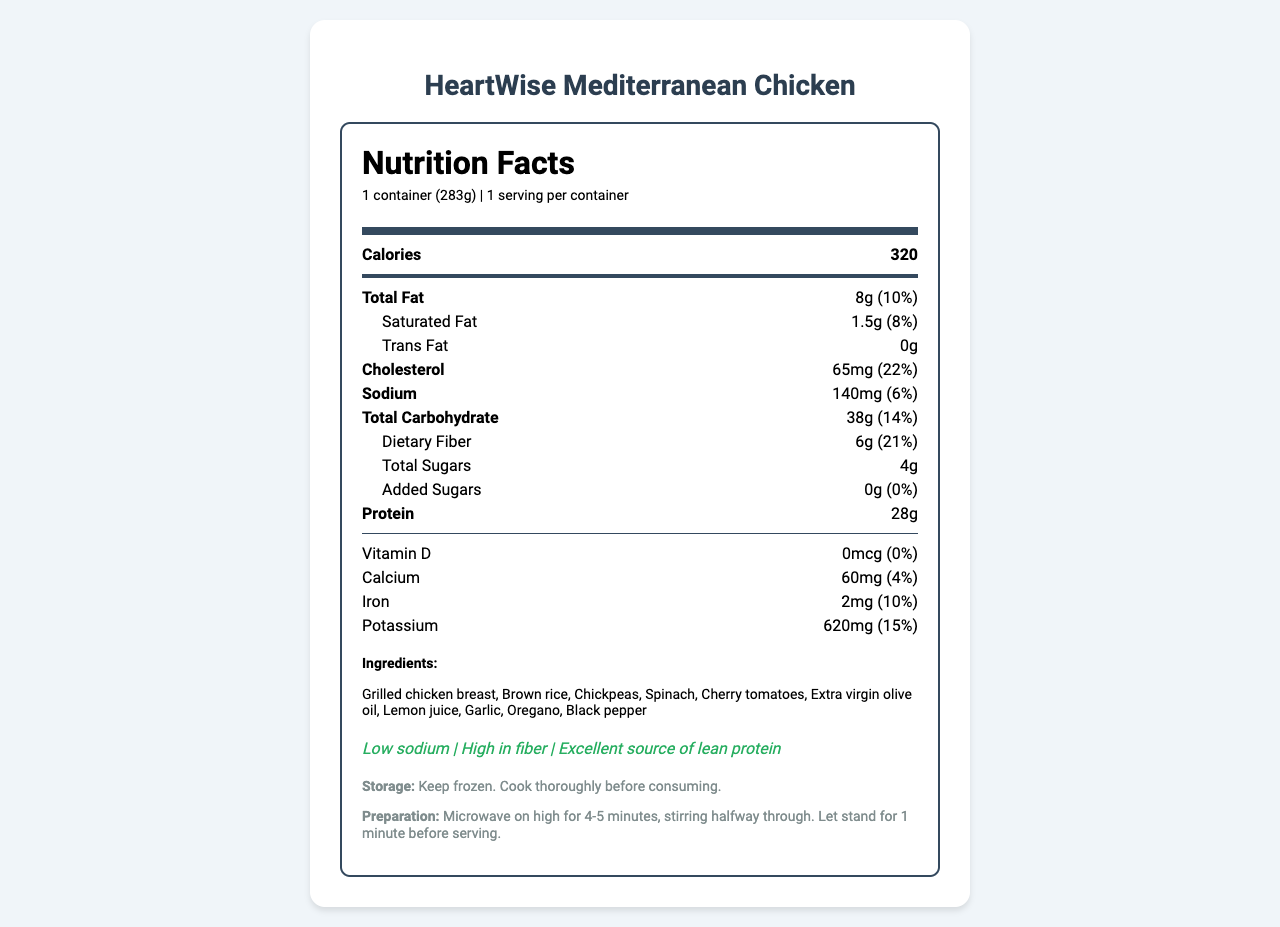what is the serving size? The serving size information is provided right below the product name in the nutrition label section.
Answer: 1 container (283g) how many calories are in one serving? The calories for one serving are listed at the top center of the nutrition facts label.
Answer: 320 what is the amount of sodium in this meal? The sodium amount is listed under the nutrition facts and next to the daily value percentage.
Answer: 140mg how much protein does this meal contain? The protein amount is listed towards the bottom section of the nutrition facts label.
Answer: 28g what is the total fat content? The total fat content is found near the top of the nutrition facts and is written as "Total Fat 8g (10%)".
Answer: 8g (10%) what are the three main health claims made about this product? The health claims are listed towards the bottom of the document under the heading "health-claims".
Answer: Low sodium, High in fiber, Excellent source of lean protein which nutrient has the highest daily value percentage? A. Total Fat B. Cholesterol C. Sodium D. Dietary Fiber E. Protein The daily value percentages for the nutrients are listed next to their amounts, and cholesterol has the highest daily value percentage at 22%.
Answer: B. Cholesterol what ingredient is used as a seasoning in this meal? A. Oregano B. Lemon juice C. Brown rice D. Chicken breast The ingredients list "Oregano" is used as a seasoning, while options B, C, and D are core ingredients.
Answer: A. Oregano is this meal suitable for someone who needs a high calcium diet? The meal provides only 4% of the daily value for calcium, which is relatively low.
Answer: No does the product contain any allergens? The allergens section specifies "None".
Answer: No what kind of oil is used in this meal? The ingredient list includes "Extra virgin olive oil".
Answer: Extra virgin olive oil what is the main idea of this document? The document provides comprehensive nutritional information, ingredient list, health benefits, storage, and preparation instructions for the product.
Answer: A detailed nutrition facts label for a low-sodium, heart-healthy frozen meal option called HeartWise Mediterranean Chicken, showcasing its nutrition content, ingredients, health claims, and preparation instructions. is this product a good source of vitamin D? The nutrition label states that the meal contains 0mcg of Vitamin D, which is 0% of the daily value requirement.
Answer: No what is the recommended cooking method for this meal? The preparation instructions at the bottom of the label describe how to cook the meal.
Answer: Microwave on high for 4-5 minutes, stirring halfway through. Let stand for 1 minute before serving. where is the information about the manufacturer found? The nutrition label does not specify details about the location or further details about the manufacturer, "HealthyChoice Foods".
Answer: Not enough information how much dietary fiber is in this meal? The dietary fiber amount is listed under the total carbohydrate with its daily value percentage.
Answer: 6g (21%) 